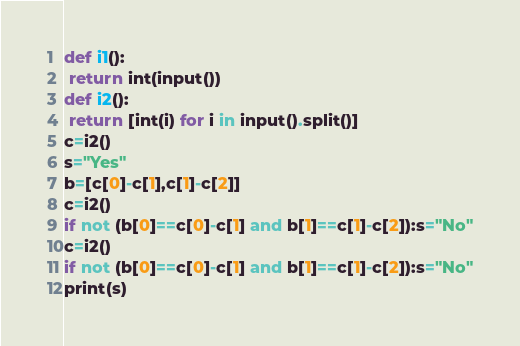<code> <loc_0><loc_0><loc_500><loc_500><_Python_>def i1():
 return int(input())
def i2():
 return [int(i) for i in input().split()]
c=i2()
s="Yes"
b=[c[0]-c[1],c[1]-c[2]]
c=i2()
if not (b[0]==c[0]-c[1] and b[1]==c[1]-c[2]):s="No"
c=i2()
if not (b[0]==c[0]-c[1] and b[1]==c[1]-c[2]):s="No"
print(s)</code> 